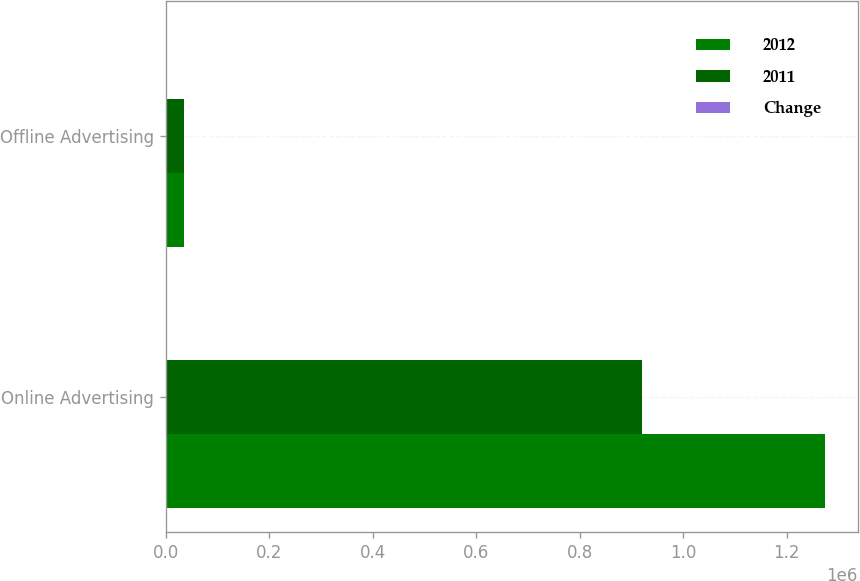Convert chart to OTSL. <chart><loc_0><loc_0><loc_500><loc_500><stacked_bar_chart><ecel><fcel>Online Advertising<fcel>Offline Advertising<nl><fcel>2012<fcel>1.27364e+06<fcel>35492<nl><fcel>2011<fcel>919214<fcel>35470<nl><fcel>Change<fcel>38.6<fcel>0.1<nl></chart> 